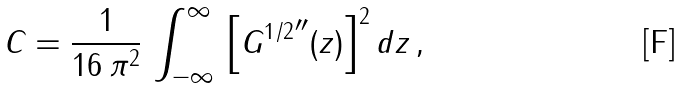Convert formula to latex. <formula><loc_0><loc_0><loc_500><loc_500>C = \frac { 1 } { 1 6 \, { \pi } ^ { 2 } } \, \int _ { - \infty } ^ { \infty } \, { \left [ { G ^ { 1 / 2 } } ^ { \prime \prime } ( z ) \right ] } ^ { 2 } \, d z \, ,</formula> 